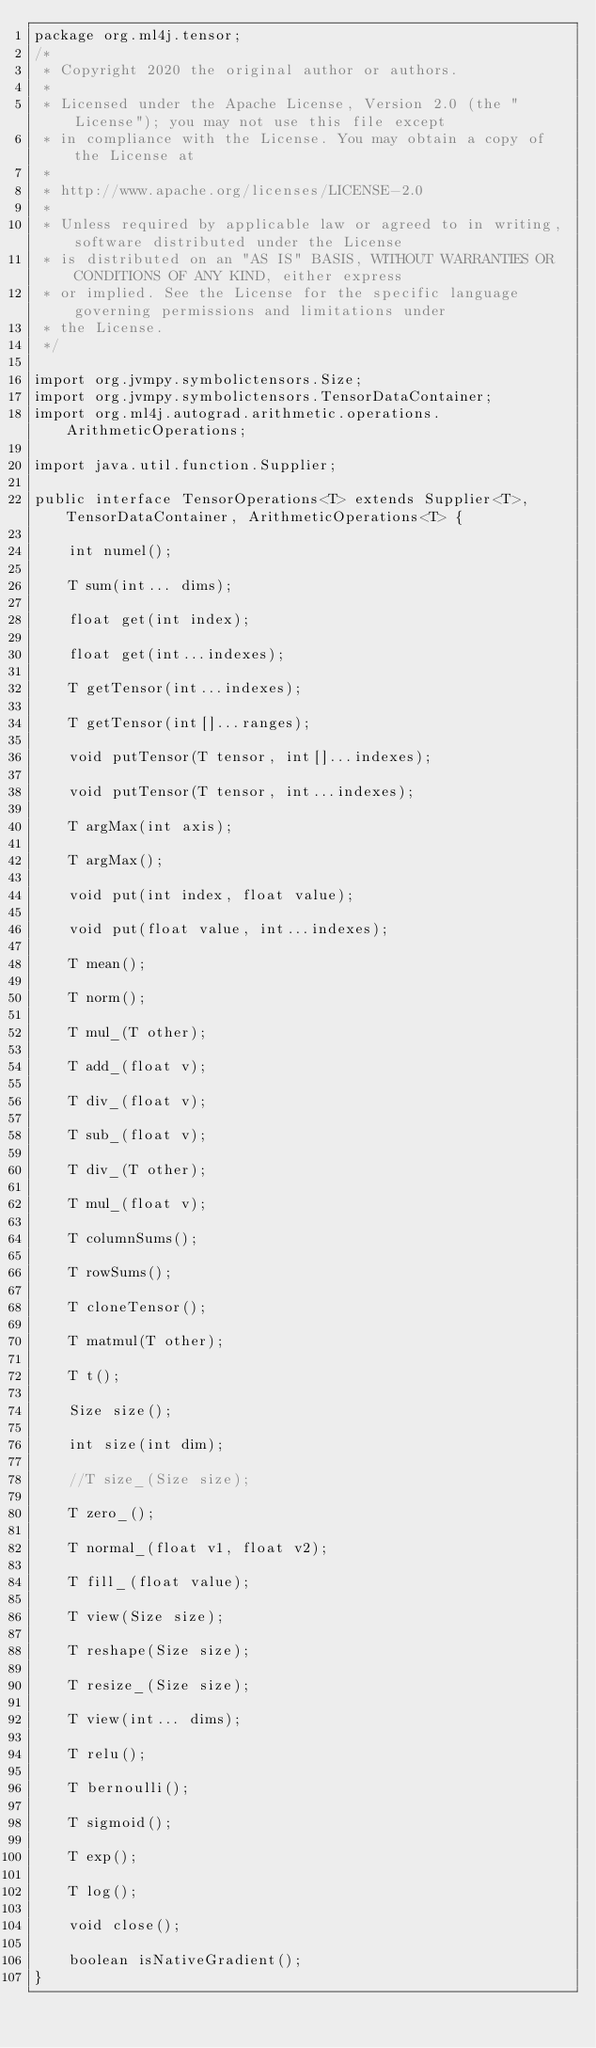Convert code to text. <code><loc_0><loc_0><loc_500><loc_500><_Java_>package org.ml4j.tensor;
/*
 * Copyright 2020 the original author or authors.
 *
 * Licensed under the Apache License, Version 2.0 (the "License"); you may not use this file except
 * in compliance with the License. You may obtain a copy of the License at
 *
 * http://www.apache.org/licenses/LICENSE-2.0
 *
 * Unless required by applicable law or agreed to in writing, software distributed under the License
 * is distributed on an "AS IS" BASIS, WITHOUT WARRANTIES OR CONDITIONS OF ANY KIND, either express
 * or implied. See the License for the specific language governing permissions and limitations under
 * the License.
 */

import org.jvmpy.symbolictensors.Size;
import org.jvmpy.symbolictensors.TensorDataContainer;
import org.ml4j.autograd.arithmetic.operations.ArithmeticOperations;

import java.util.function.Supplier;

public interface TensorOperations<T> extends Supplier<T>, TensorDataContainer, ArithmeticOperations<T> {

    int numel();

    T sum(int... dims);

    float get(int index);

    float get(int...indexes);

    T getTensor(int...indexes);

    T getTensor(int[]...ranges);

    void putTensor(T tensor, int[]...indexes);

    void putTensor(T tensor, int...indexes);

    T argMax(int axis);

    T argMax();

    void put(int index, float value);

    void put(float value, int...indexes);

    T mean();

    T norm();

    T mul_(T other);

    T add_(float v);

    T div_(float v);

    T sub_(float v);

    T div_(T other);

    T mul_(float v);

    T columnSums();

    T rowSums();

    T cloneTensor();

    T matmul(T other);

    T t();

    Size size();

    int size(int dim);

    //T size_(Size size);

    T zero_();

    T normal_(float v1, float v2);

    T fill_(float value);

    T view(Size size);

    T reshape(Size size);

    T resize_(Size size);
    
    T view(int... dims);

    T relu();

    T bernoulli();

    T sigmoid();

    T exp();

    T log();

    void close();
    
    boolean isNativeGradient();
}</code> 